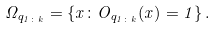Convert formula to latex. <formula><loc_0><loc_0><loc_500><loc_500>\Omega _ { q _ { 1 \colon k } } = \{ x \colon O _ { q _ { 1 \colon k } } ( x ) = 1 \} \, .</formula> 